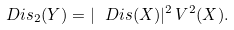<formula> <loc_0><loc_0><loc_500><loc_500>\ D i s _ { 2 } ( Y ) = | \ D i s ( X ) | ^ { 2 } \, V ^ { 2 } ( X ) .</formula> 